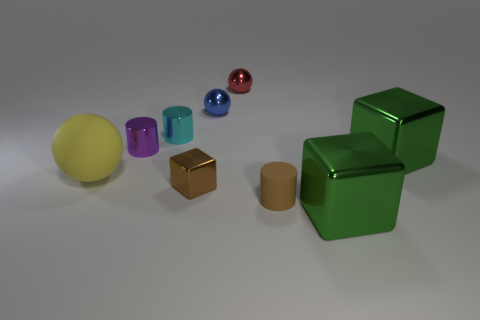Subtract all yellow matte balls. How many balls are left? 2 Subtract all brown blocks. How many blocks are left? 2 Subtract 1 blocks. How many blocks are left? 2 Add 1 green metallic cubes. How many objects exist? 10 Subtract all cylinders. How many objects are left? 6 Subtract all blue balls. How many cyan cylinders are left? 1 Subtract all small brown objects. Subtract all brown cubes. How many objects are left? 6 Add 2 rubber cylinders. How many rubber cylinders are left? 3 Add 5 large brown shiny objects. How many large brown shiny objects exist? 5 Subtract 0 brown spheres. How many objects are left? 9 